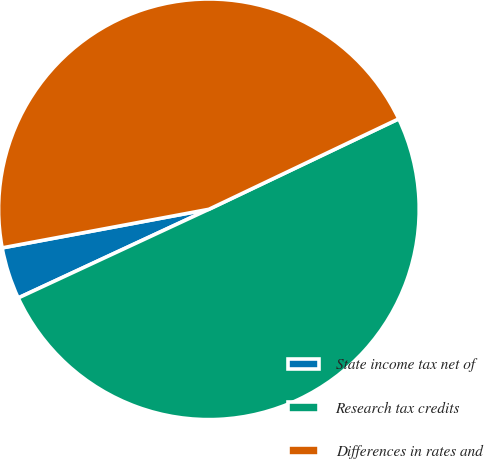Convert chart. <chart><loc_0><loc_0><loc_500><loc_500><pie_chart><fcel>State income tax net of<fcel>Research tax credits<fcel>Differences in rates and<nl><fcel>3.99%<fcel>50.15%<fcel>45.86%<nl></chart> 